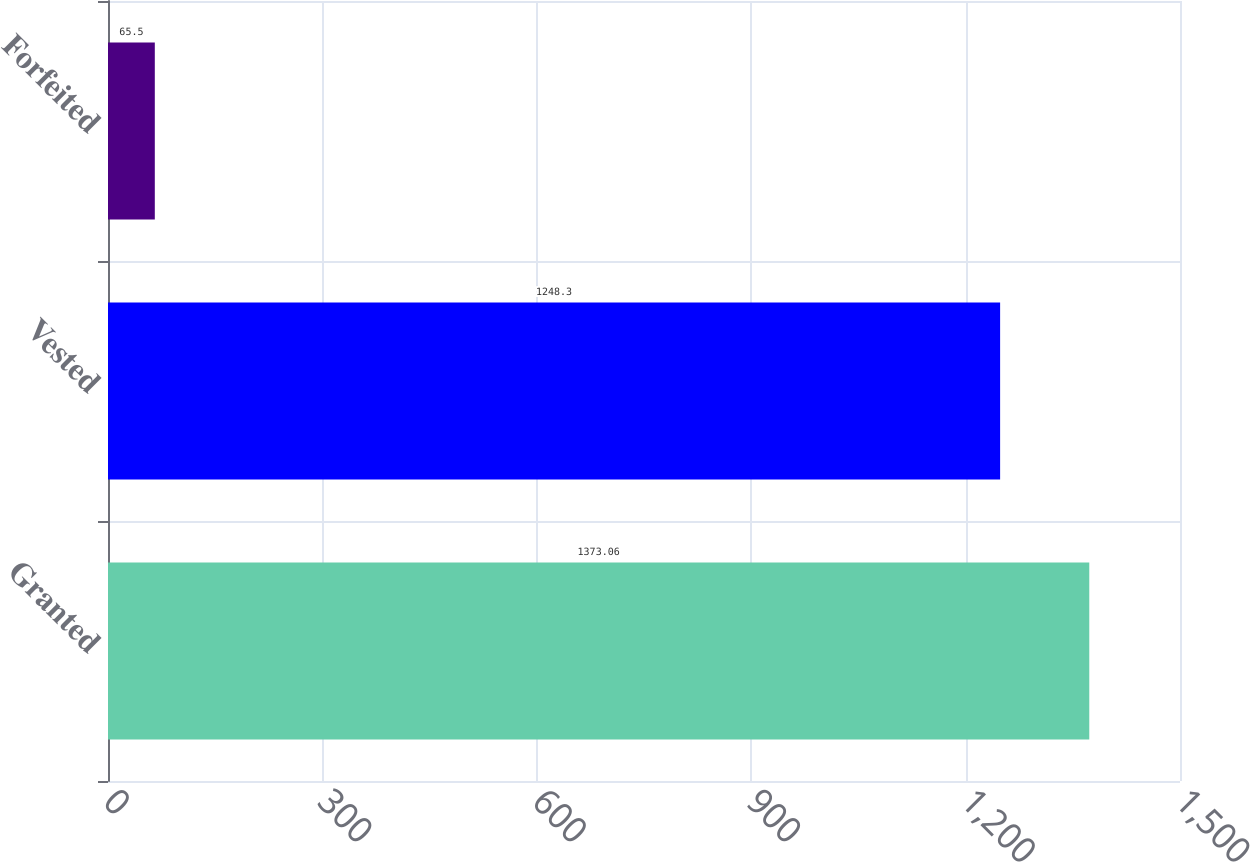Convert chart to OTSL. <chart><loc_0><loc_0><loc_500><loc_500><bar_chart><fcel>Granted<fcel>Vested<fcel>Forfeited<nl><fcel>1373.06<fcel>1248.3<fcel>65.5<nl></chart> 